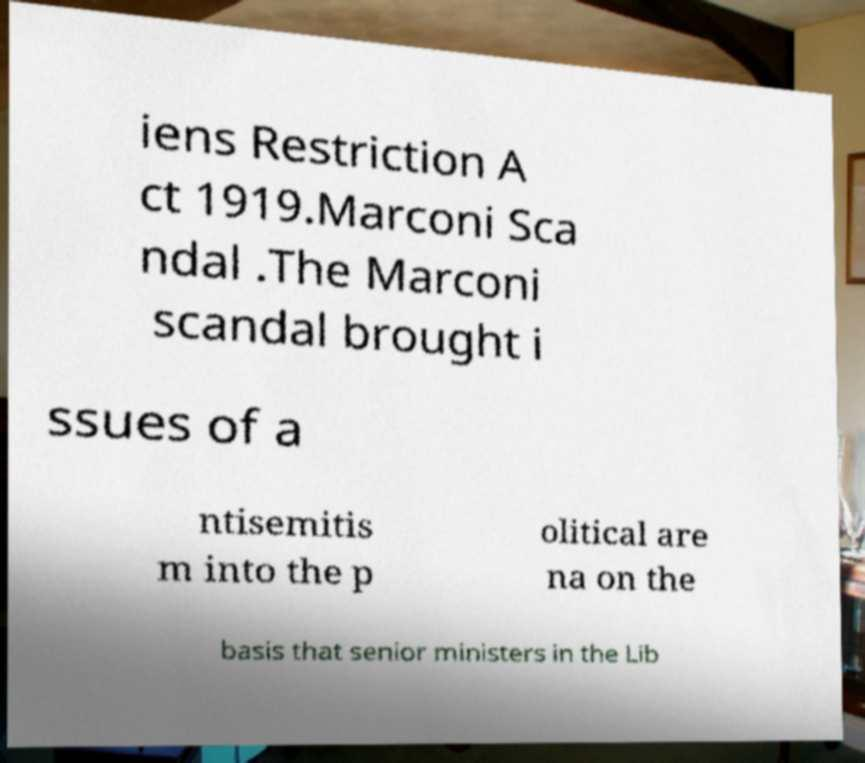Please read and relay the text visible in this image. What does it say? iens Restriction A ct 1919.Marconi Sca ndal .The Marconi scandal brought i ssues of a ntisemitis m into the p olitical are na on the basis that senior ministers in the Lib 